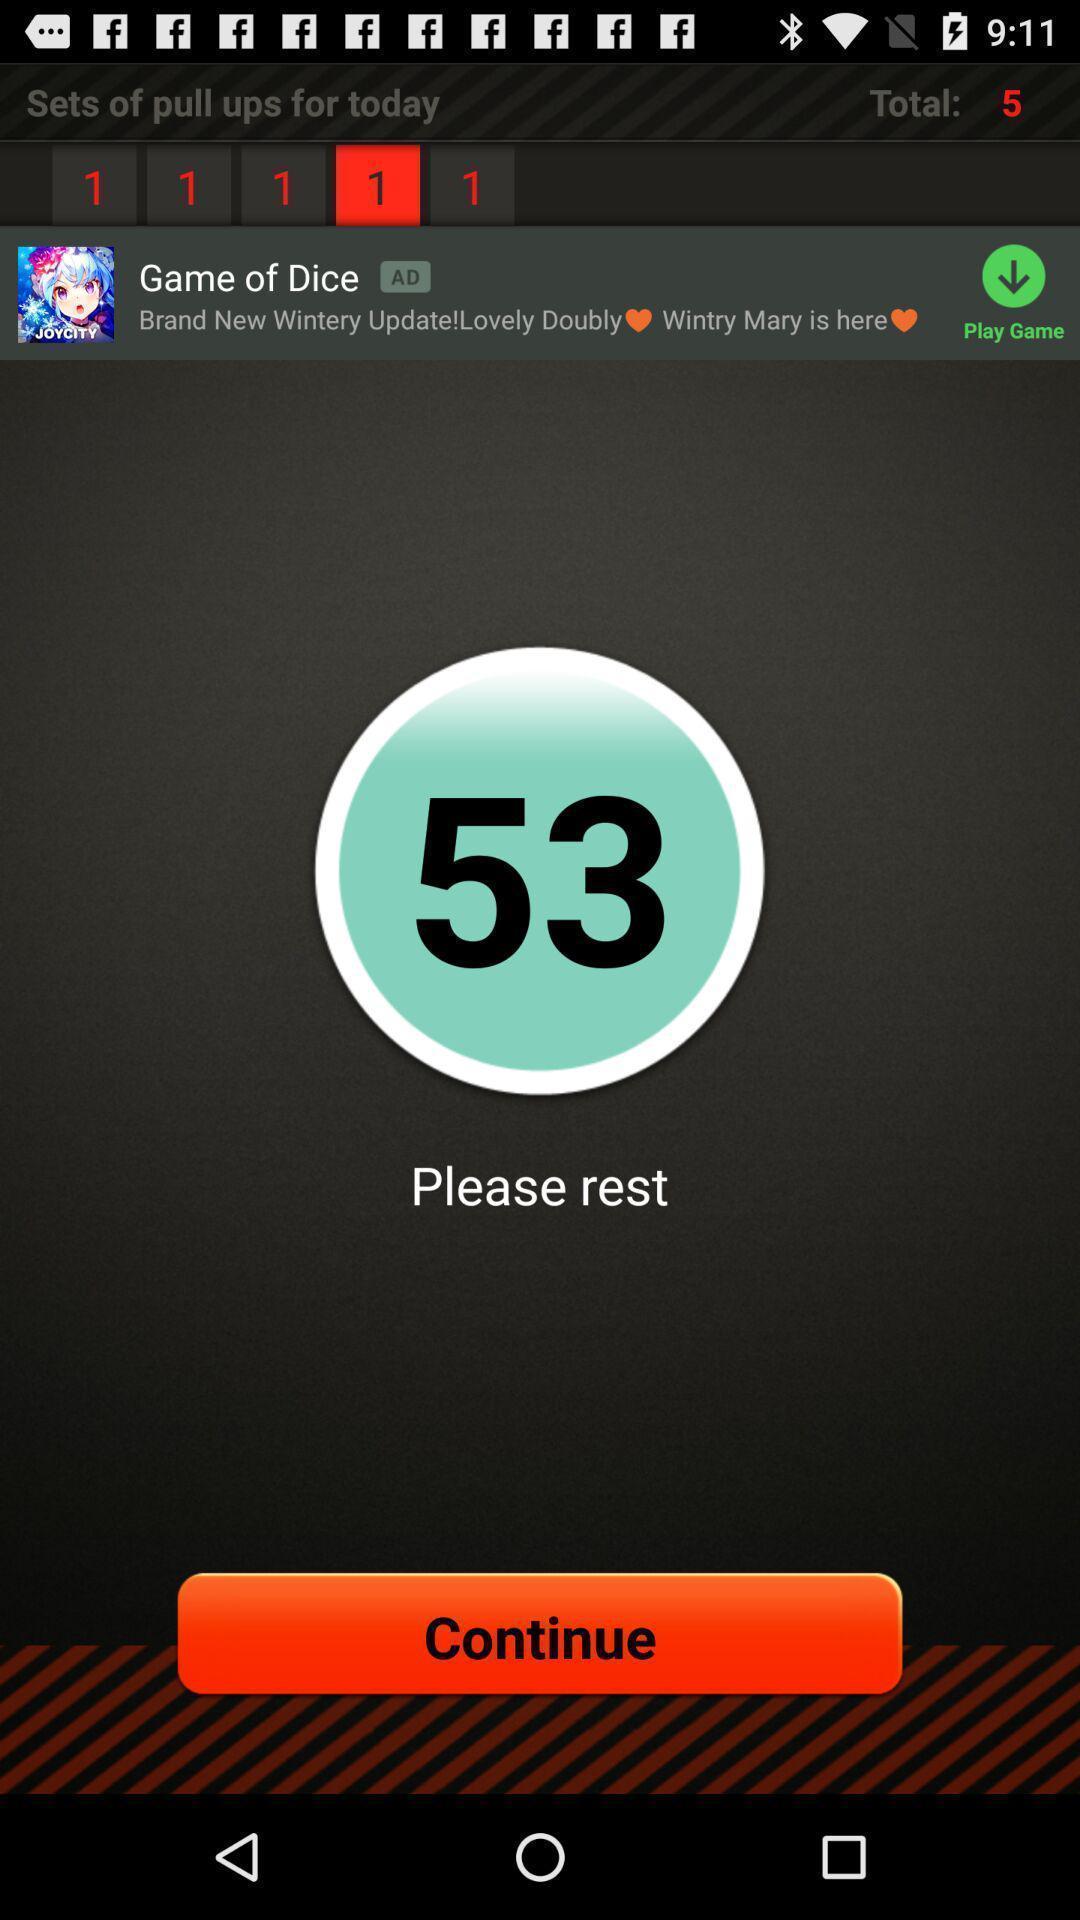Provide a detailed account of this screenshot. Sets of pull ups in a fitness app. 